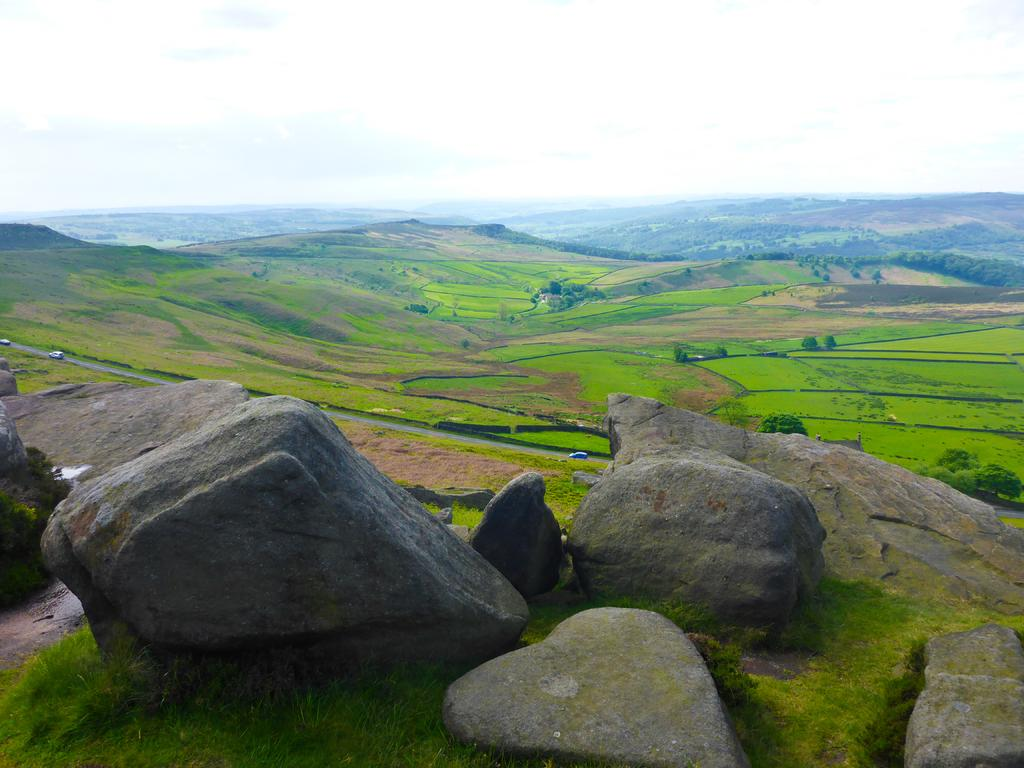Where was the image taken? The image was taken outside. What can be seen at the bottom of the image? There are rocks at the bottom of the image. What type of terrain is visible in the front of the image? There are mountains covered with grass in the front of the image. What is visible at the top of the image? The sky is visible at the top of the image. What can be observed in the sky? There are clouds in the sky. How much does the ticket cost for the voyage in the image? There is no ticket or voyage present in the image; it features an outdoor scene with rocks, mountains, and clouds. 